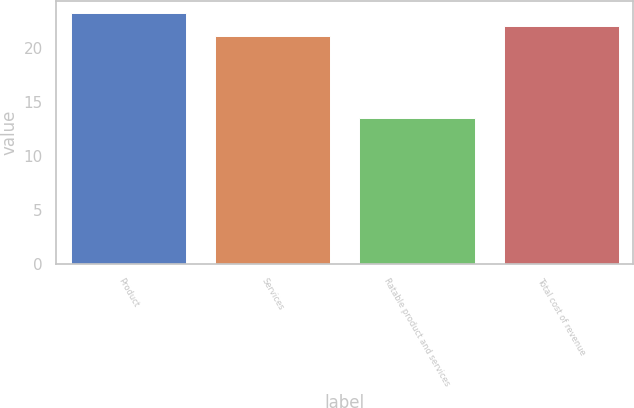Convert chart. <chart><loc_0><loc_0><loc_500><loc_500><bar_chart><fcel>Product<fcel>Services<fcel>Ratable product and services<fcel>Total cost of revenue<nl><fcel>23.2<fcel>21.1<fcel>13.5<fcel>22.07<nl></chart> 